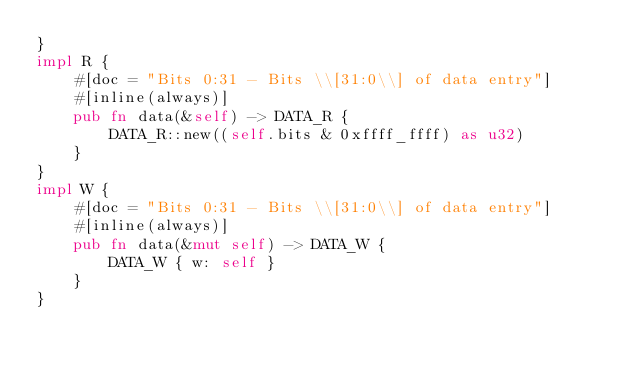Convert code to text. <code><loc_0><loc_0><loc_500><loc_500><_Rust_>}
impl R {
    #[doc = "Bits 0:31 - Bits \\[31:0\\] of data entry"]
    #[inline(always)]
    pub fn data(&self) -> DATA_R {
        DATA_R::new((self.bits & 0xffff_ffff) as u32)
    }
}
impl W {
    #[doc = "Bits 0:31 - Bits \\[31:0\\] of data entry"]
    #[inline(always)]
    pub fn data(&mut self) -> DATA_W {
        DATA_W { w: self }
    }
}
</code> 